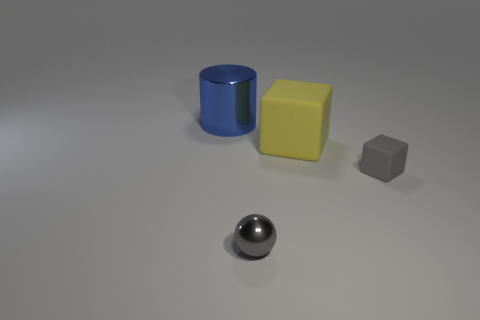Add 2 small green rubber things. How many objects exist? 6 Subtract all spheres. How many objects are left? 3 Subtract 0 brown balls. How many objects are left? 4 Subtract all gray blocks. Subtract all gray balls. How many objects are left? 2 Add 1 small blocks. How many small blocks are left? 2 Add 3 tiny cyan blocks. How many tiny cyan blocks exist? 3 